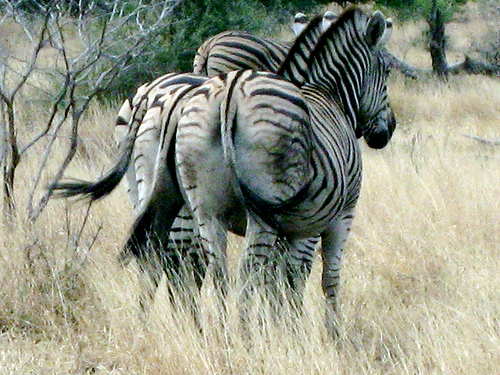How many zebras are there? 2 